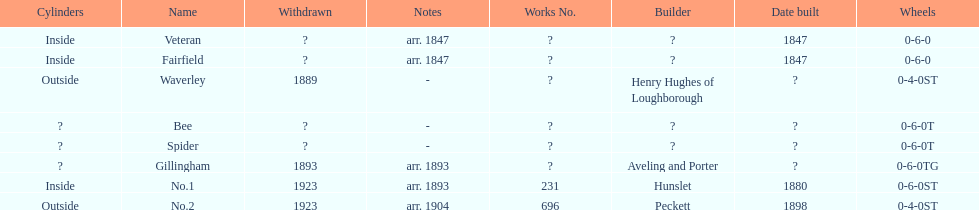Other than fairfield, what else was built in 1847? Veteran. 